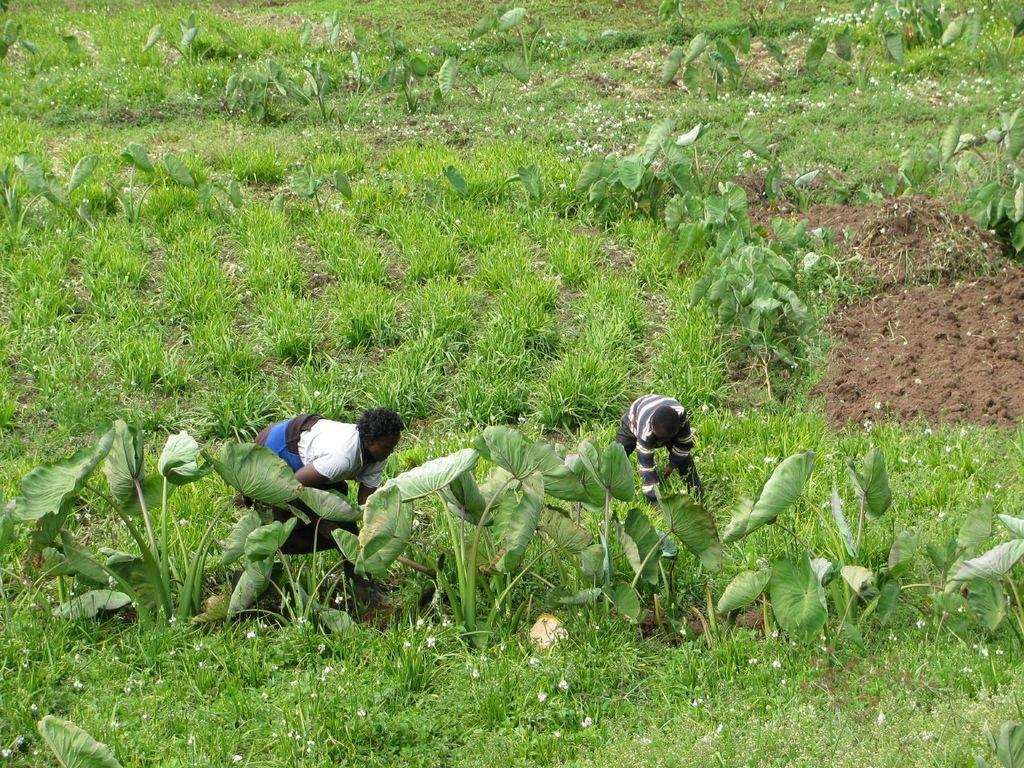What are the two persons in the image doing? The two persons in the image are bending. What is the person holding in the image? There is a person holding an object in the image. What type of surface can be seen towards the right side of the image? There is soil towards the right side of the image. What type of vegetation is present in the image? There are plants, grass, and flowers in the image. What type of approval is given to the person holding the object in the image? There is no indication of approval or any evaluation in the image; it simply shows a person holding an object. What reward is the person with the bent posture receiving for their actions in the image? There is no reward or any indication of a reward system in the image; it simply shows two persons bending. 